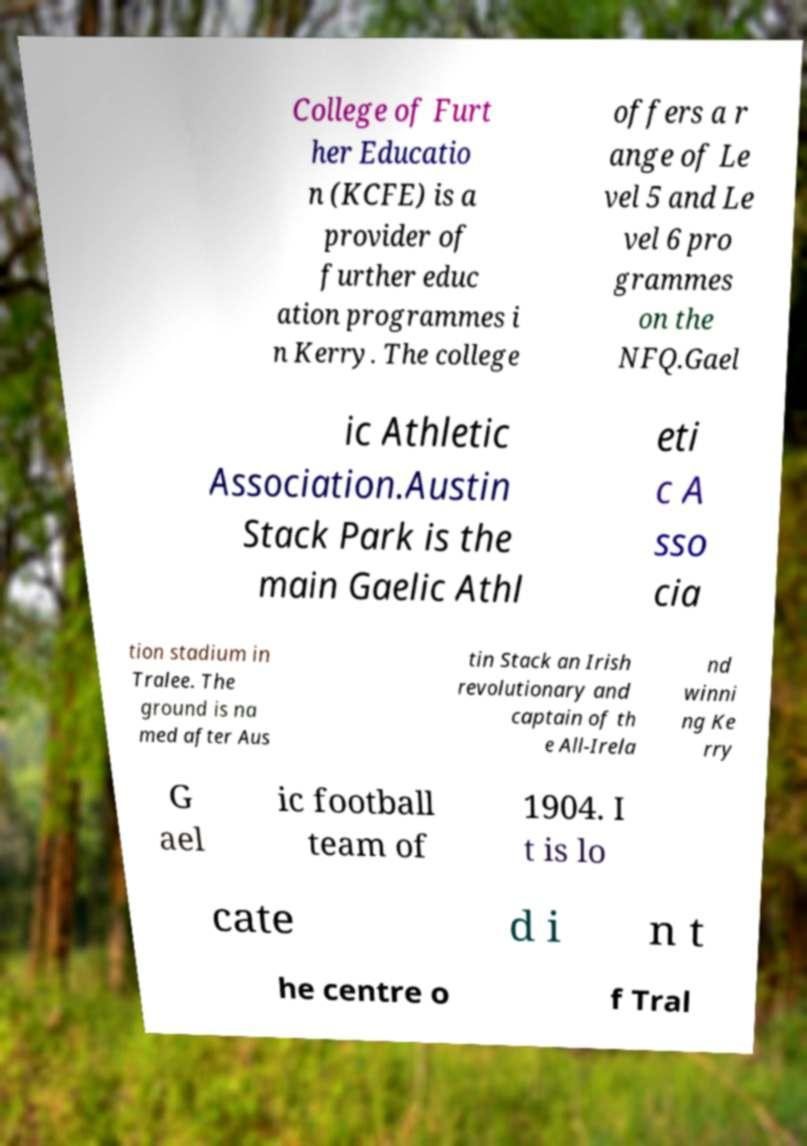Could you assist in decoding the text presented in this image and type it out clearly? College of Furt her Educatio n (KCFE) is a provider of further educ ation programmes i n Kerry. The college offers a r ange of Le vel 5 and Le vel 6 pro grammes on the NFQ.Gael ic Athletic Association.Austin Stack Park is the main Gaelic Athl eti c A sso cia tion stadium in Tralee. The ground is na med after Aus tin Stack an Irish revolutionary and captain of th e All-Irela nd winni ng Ke rry G ael ic football team of 1904. I t is lo cate d i n t he centre o f Tral 